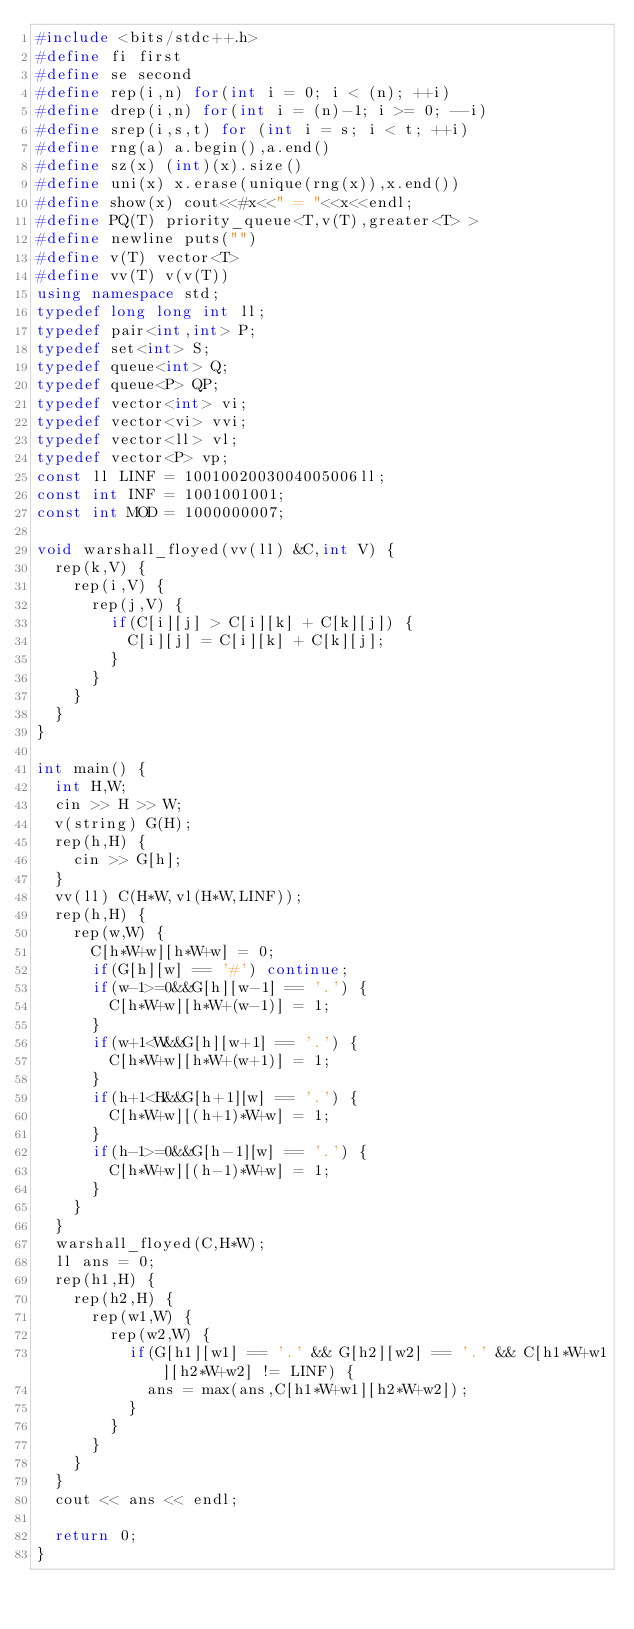<code> <loc_0><loc_0><loc_500><loc_500><_C++_>#include <bits/stdc++.h>
#define fi first
#define se second
#define rep(i,n) for(int i = 0; i < (n); ++i)
#define drep(i,n) for(int i = (n)-1; i >= 0; --i)
#define srep(i,s,t) for (int i = s; i < t; ++i)
#define rng(a) a.begin(),a.end()
#define sz(x) (int)(x).size()
#define uni(x) x.erase(unique(rng(x)),x.end())
#define show(x) cout<<#x<<" = "<<x<<endl;
#define PQ(T) priority_queue<T,v(T),greater<T> >
#define newline puts("")
#define v(T) vector<T>
#define vv(T) v(v(T))
using namespace std;
typedef long long int ll;
typedef pair<int,int> P;
typedef set<int> S;
typedef queue<int> Q;
typedef queue<P> QP;
typedef vector<int> vi;
typedef vector<vi> vvi;
typedef vector<ll> vl;
typedef vector<P> vp;
const ll LINF = 1001002003004005006ll;
const int INF = 1001001001;
const int MOD = 1000000007;

void warshall_floyed(vv(ll) &C,int V) {
  rep(k,V) {
    rep(i,V) {
      rep(j,V) {
        if(C[i][j] > C[i][k] + C[k][j]) {
          C[i][j] = C[i][k] + C[k][j];
        }
      }
    }
  }
}
  
int main() {
  int H,W;
  cin >> H >> W;
  v(string) G(H);
  rep(h,H) {
    cin >> G[h];
  }
  vv(ll) C(H*W,vl(H*W,LINF));
  rep(h,H) {
    rep(w,W) {
      C[h*W+w][h*W+w] = 0;
      if(G[h][w] == '#') continue;
      if(w-1>=0&&G[h][w-1] == '.') {
        C[h*W+w][h*W+(w-1)] = 1;
      }
      if(w+1<W&&G[h][w+1] == '.') {
        C[h*W+w][h*W+(w+1)] = 1;
      }
      if(h+1<H&&G[h+1][w] == '.') {
        C[h*W+w][(h+1)*W+w] = 1;
      }
      if(h-1>=0&&G[h-1][w] == '.') {
        C[h*W+w][(h-1)*W+w] = 1;
      }
    }
  }
  warshall_floyed(C,H*W);
  ll ans = 0;
  rep(h1,H) {
    rep(h2,H) {
      rep(w1,W) {
        rep(w2,W) {
          if(G[h1][w1] == '.' && G[h2][w2] == '.' && C[h1*W+w1][h2*W+w2] != LINF) {
            ans = max(ans,C[h1*W+w1][h2*W+w2]);
          }
        }
      }
    }
  }
  cout << ans << endl;

  return 0;
}</code> 